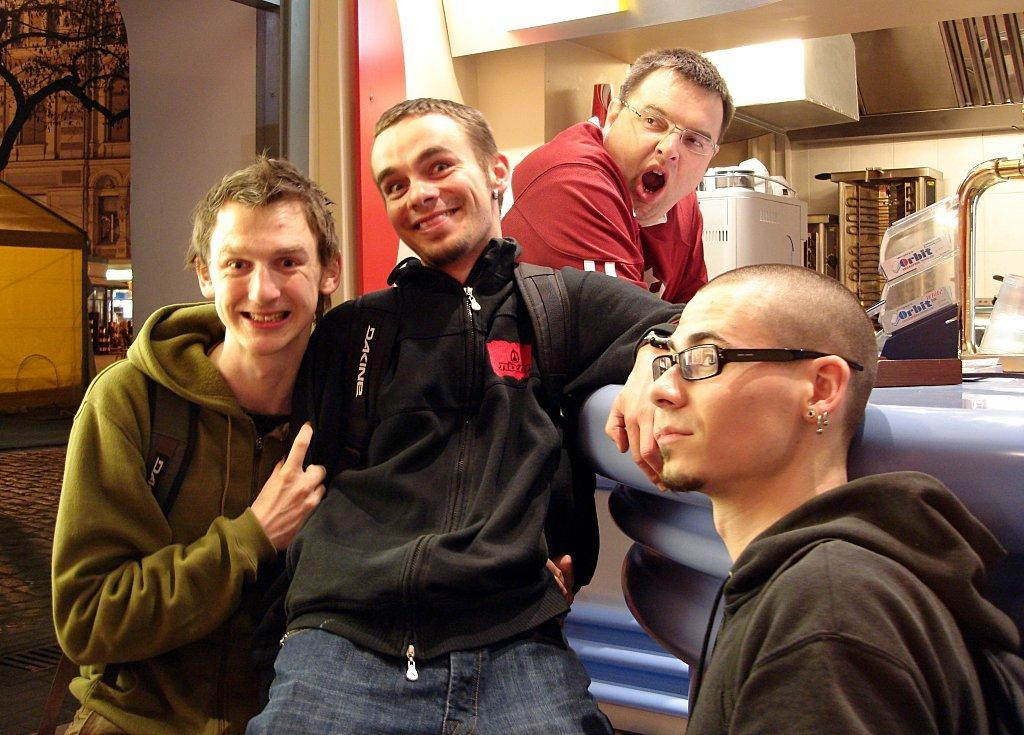How many men are in the image? There are three men in the image. What are the men wearing? The men are wearing clothes. Are any of the men wearing goggles? Yes, two of the men are wearing goggles. Are any of the men wearing earrings? Yes, two of the men are wearing earrings. What type of path can be seen in the image? There is a footpath in the image. What natural element is present in the image? There is a tree in the image. What type of illumination is visible in the image? There is a light in the image. Can you describe any other objects in the image? There are other objects in the image, but their specific details are not mentioned in the provided facts. What time of day is it in the image, and what is the spoon used for? The provided facts do not mention the time of day or the presence of a spoon in the image. 